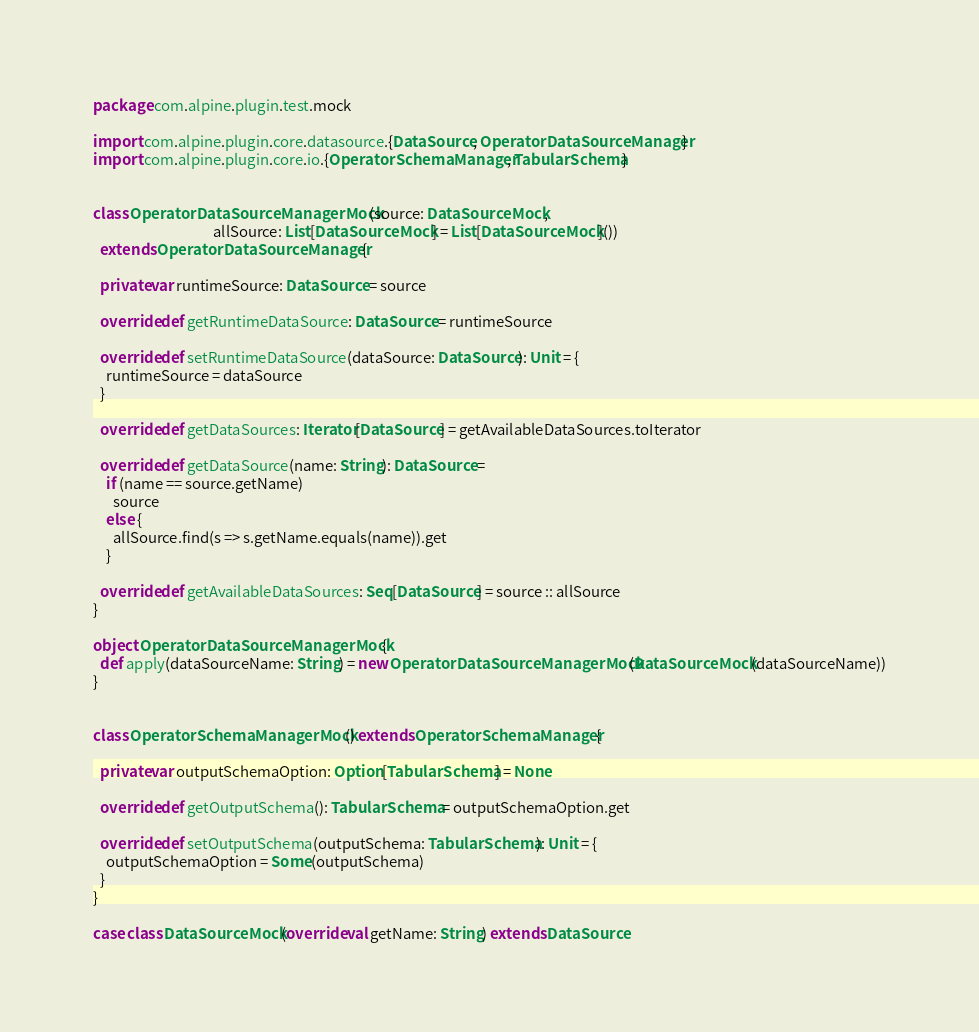<code> <loc_0><loc_0><loc_500><loc_500><_Scala_>package com.alpine.plugin.test.mock

import com.alpine.plugin.core.datasource.{DataSource, OperatorDataSourceManager}
import com.alpine.plugin.core.io.{OperatorSchemaManager, TabularSchema}


class OperatorDataSourceManagerMock(source: DataSourceMock,
                                    allSource: List[DataSourceMock] = List[DataSourceMock]())
  extends OperatorDataSourceManager {

  private var runtimeSource: DataSource = source

  override def getRuntimeDataSource: DataSource = runtimeSource

  override def setRuntimeDataSource(dataSource: DataSource): Unit = {
    runtimeSource = dataSource
  }

  override def getDataSources: Iterator[DataSource] = getAvailableDataSources.toIterator

  override def getDataSource(name: String): DataSource =
    if (name == source.getName)
      source
    else {
      allSource.find(s => s.getName.equals(name)).get
    }

  override def getAvailableDataSources: Seq[DataSource] = source :: allSource
}

object OperatorDataSourceManagerMock {
  def apply(dataSourceName: String) = new OperatorDataSourceManagerMock(DataSourceMock(dataSourceName))
}


class OperatorSchemaManagerMock() extends OperatorSchemaManager {

  private var outputSchemaOption: Option[TabularSchema] = None

  override def getOutputSchema(): TabularSchema = outputSchemaOption.get

  override def setOutputSchema(outputSchema: TabularSchema): Unit = {
    outputSchemaOption = Some(outputSchema)
  }
}

case class DataSourceMock(override val getName: String) extends DataSource
</code> 